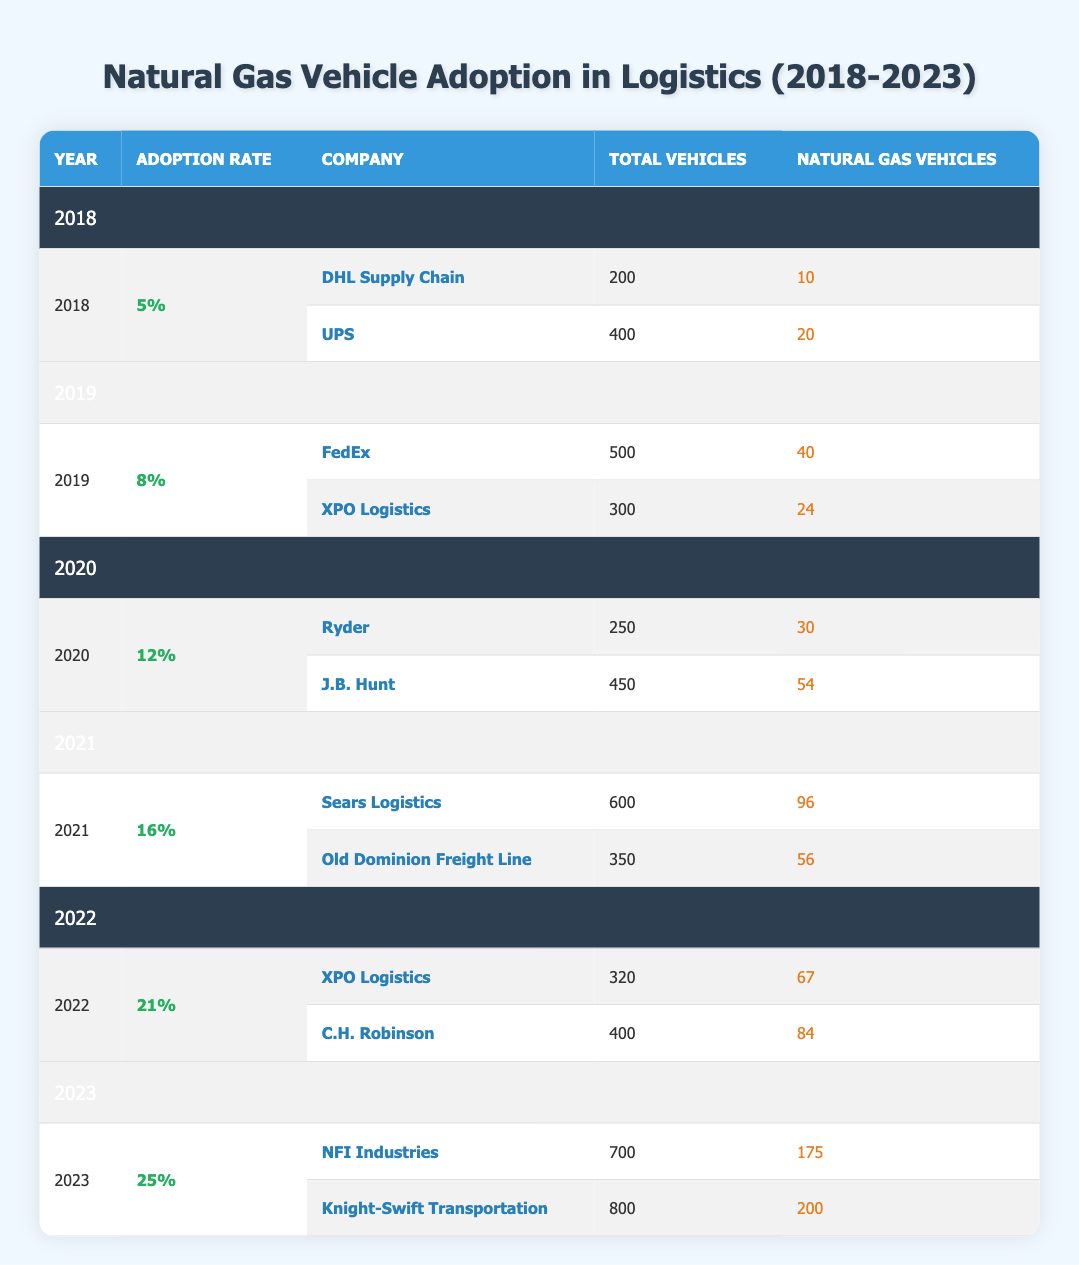What was the adoption rate of natural gas vehicles in the year 2020? Referring to the table, under the year 2020, the adoption rate is specified as 12%.
Answer: 12% Which company had the highest number of natural gas vehicles in 2023? In 2023, NFI Industries has 175 natural gas vehicles, while Knight-Swift Transportation has 200 natural gas vehicles. Therefore, Knight-Swift Transportation had the highest number of natural gas vehicles in 2023.
Answer: Knight-Swift Transportation How many companies adopted natural gas vehicles in 2021 compared to 2018? Both years have two companies listed in the table. In 2021, the companies are Sears Logistics and Old Dominion Freight Line, while in 2018, the companies are DHL Supply Chain and UPS. So, the number of companies that adopted natural gas vehicles remained the same between these years.
Answer: Same (2 companies) What is the total number of natural gas vehicles adopted by C.H. Robinson and XPO Logistics in 2022? For 2022, C.H. Robinson has 84 natural gas vehicles, and XPO Logistics has 67 natural gas vehicles. Adding these together gives 84 + 67 = 151.
Answer: 151 Is it true that the adoption rate of natural gas vehicles increased every year from 2018 to 2023? Looking at the table, the adoption rates for each year are 5%, 8%, 12%, 16%, 21%, and 25%. Since these values are consistently increasing, this statement is indeed true.
Answer: Yes What was the average percentage of natural gas vehicle adoption from 2018 to 2023? To find the average, sum all the adoption rates from 2018 (5%), 2019 (8%), 2020 (12%), 2021 (16%), 2022 (21%), and 2023 (25%). The total is 5 + 8 + 12 + 16 + 21 + 25 = 87. There are 6 years, so 87 / 6 = 14.5%.
Answer: 14.5% How much did the total number of vehicles increase from 2018 to 2023? In 2018, the total number of vehicles was 200 (DHL + UPS) + 400 (UPS) = 600. In 2023, it was 700 (NFI Industries) + 800 (Knight-Swift) = 1500. The increase is 1500 - 600 = 900.
Answer: 900 Which year had the highest increase in the number of natural gas vehicles compared to the previous year? By comparing the number of natural gas vehicles each year up to the next, we see the changes: 2019 (40) - 2018 (30) = 10, 2020 (30) - 2019 (40) = -10, 2021 (96) - 2020 (54) = 42, 2022 (67) - 2021 (96) = -29, 2023 (175) - 2022 (84) = 91. The highest increase is from 2022 to 2023 with 91 more natural gas vehicles.
Answer: 2023 